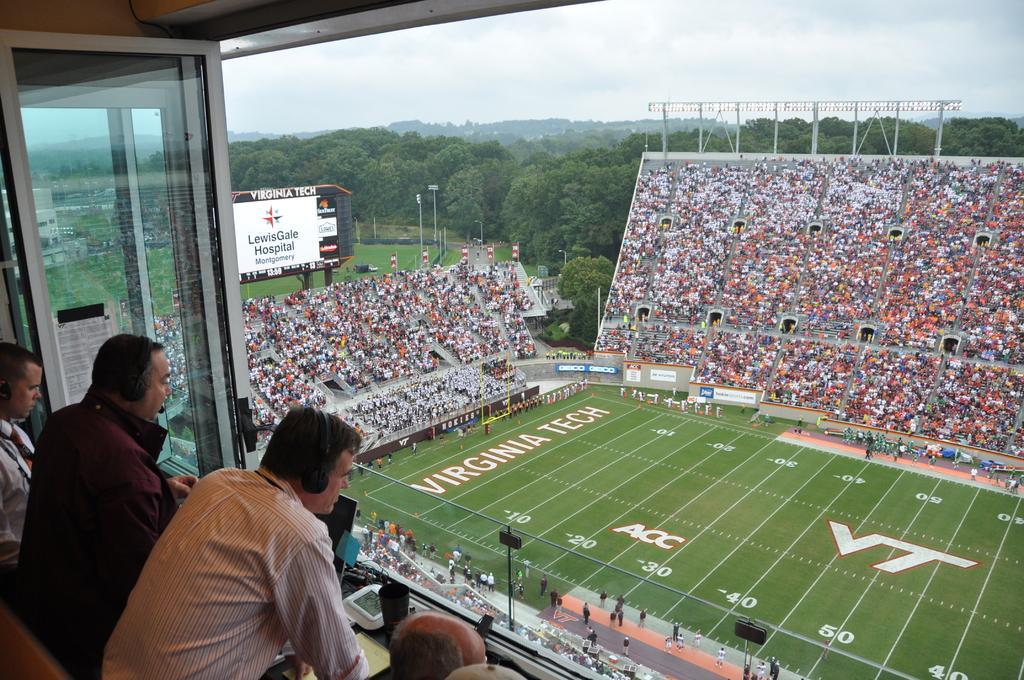Please provide a concise description of this image. In this picture we can see some people and three people are wearing headphones, there is a glass door, in front of them we can see a group of people and some people are on the ground, here we can see electric poles, hoarding, advertisement boards and some objects and in the background we can see a building, trees, sky. 